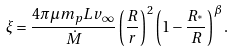<formula> <loc_0><loc_0><loc_500><loc_500>\xi = \frac { 4 \pi \mu m _ { p } L v _ { \infty } } { \dot { M } } \left ( \frac { R } { r } \right ) ^ { 2 } \left ( 1 - \frac { R _ { ^ { * } } } { R } \right ) ^ { \beta } .</formula> 